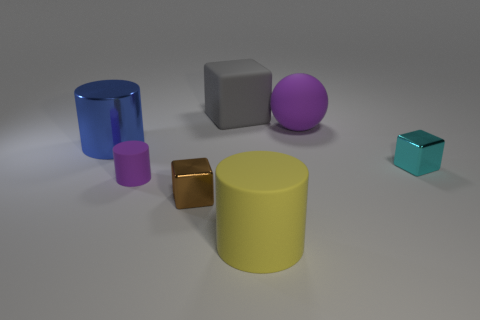What is the size of the ball that is the same color as the tiny cylinder?
Keep it short and to the point. Large. Is the material of the small cyan object the same as the brown object that is on the left side of the ball?
Your response must be concise. Yes. Is there anything else of the same color as the large matte cylinder?
Offer a very short reply. No. Is there a purple object that is left of the purple thing that is behind the small shiny object that is behind the small purple matte object?
Offer a terse response. Yes. The rubber ball has what color?
Your answer should be compact. Purple. There is a large purple rubber ball; are there any cyan metallic objects to the right of it?
Keep it short and to the point. Yes. Is the shape of the yellow rubber thing the same as the purple thing that is to the left of the yellow cylinder?
Ensure brevity in your answer.  Yes. What number of other objects are there of the same material as the blue object?
Make the answer very short. 2. The large cylinder that is in front of the small metallic object left of the tiny metal object that is to the right of the small brown cube is what color?
Provide a succinct answer. Yellow. What shape is the purple matte thing on the right side of the small shiny cube that is in front of the cyan cube?
Your response must be concise. Sphere. 